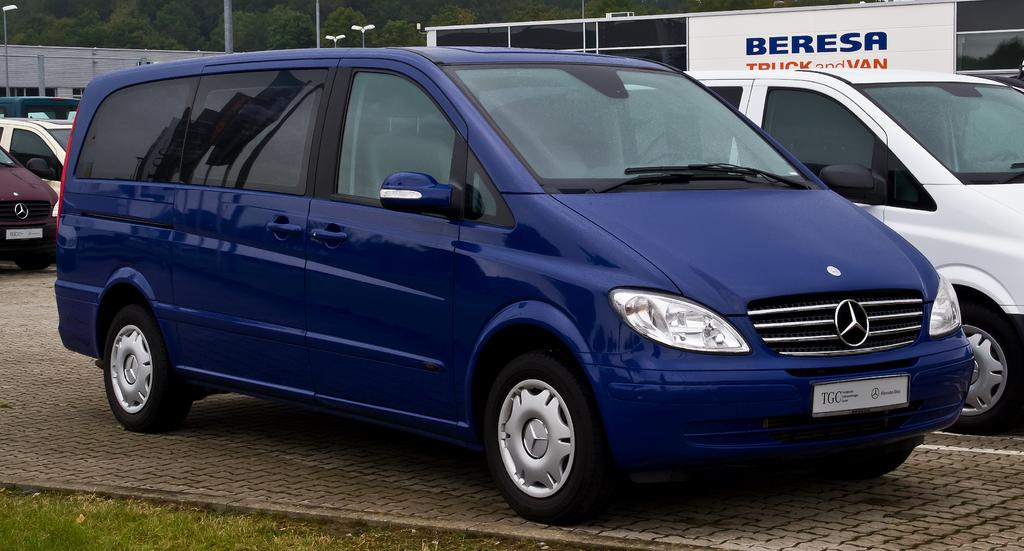What types of objects can be seen in the image? There are vehicles in the image. What type of natural environment is visible in the image? There is grass visible in the image. What can be seen in the background of the image? There are light poles, a hoarding, buildings, and trees in the background of the image. What feature of the vehicles can be identified? The vehicles have number plates. Where do the fairies live in the image? There are no fairies present in the image. What is the home of the person in the image? The image does not show a person or their home. 